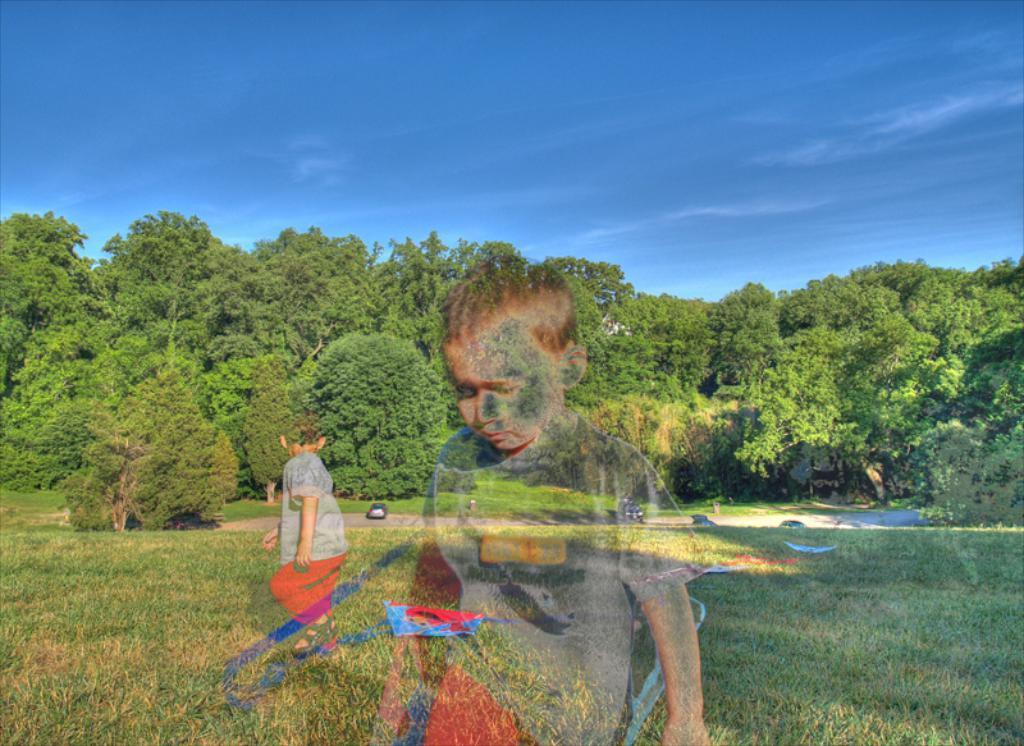Can you describe this image briefly? In this image we can see an edited picture, there is a boy on the grass and in the background there are few cars and trees and sky on the top. 